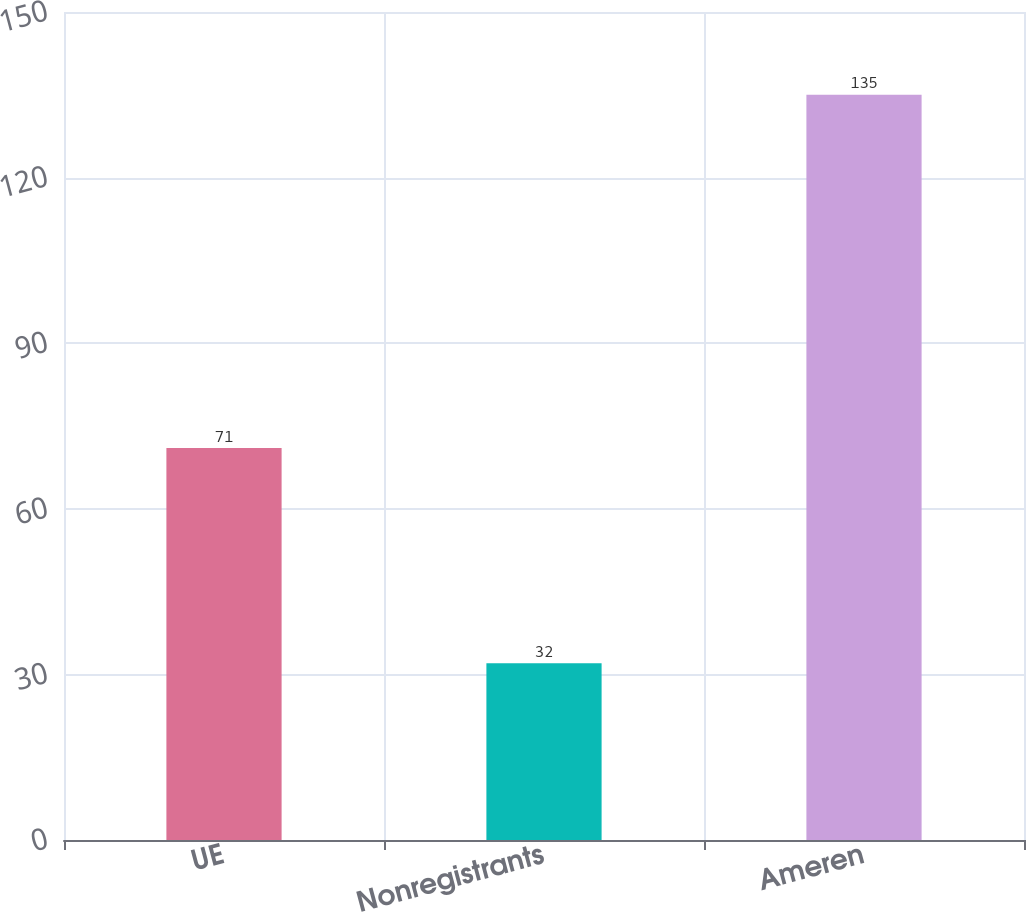Convert chart. <chart><loc_0><loc_0><loc_500><loc_500><bar_chart><fcel>UE<fcel>Nonregistrants<fcel>Ameren<nl><fcel>71<fcel>32<fcel>135<nl></chart> 